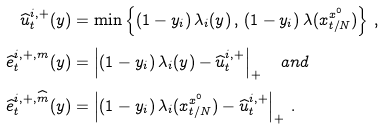<formula> <loc_0><loc_0><loc_500><loc_500>\widehat { u } _ { t } ^ { i , + } ( y ) & = \min \left \{ ( 1 - y _ { i } ) \, \lambda _ { i } ( y ) \, , \, ( 1 - y _ { i } ) \, \lambda ( x _ { t / N } ^ { x ^ { 0 } } ) \right \} \, , \\ \widehat { e } _ { t } ^ { i , + , m } ( y ) & = \left | ( 1 - y _ { i } ) \, \lambda _ { i } ( y ) - \widehat { u } _ { t } ^ { i , + } \right | _ { + } \quad a n d \\ \widehat { e } _ { t } ^ { i , + , \widehat { m } } ( y ) & = \left | ( 1 - y _ { i } ) \, \lambda _ { i } ( x _ { t / N } ^ { x ^ { 0 } } ) - \widehat { u } _ { t } ^ { i , + } \right | _ { + } \, .</formula> 